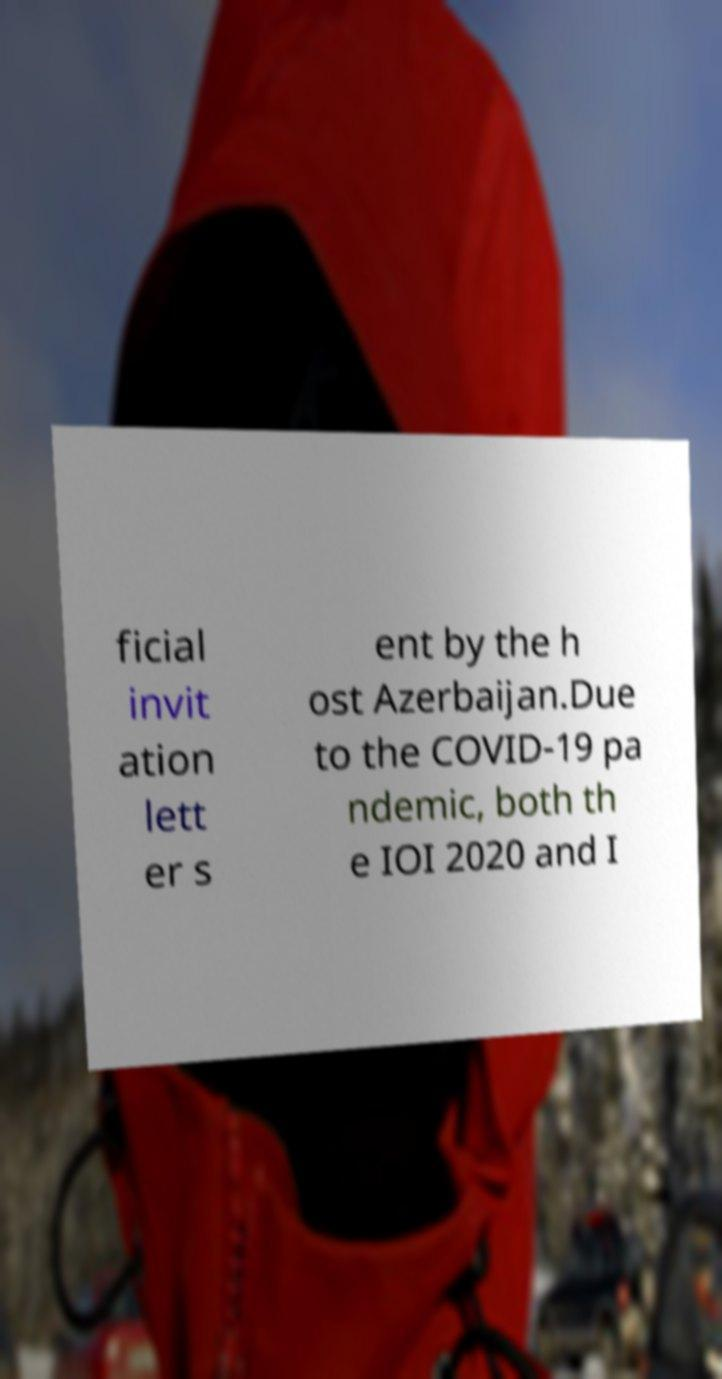For documentation purposes, I need the text within this image transcribed. Could you provide that? ficial invit ation lett er s ent by the h ost Azerbaijan.Due to the COVID-19 pa ndemic, both th e IOI 2020 and I 